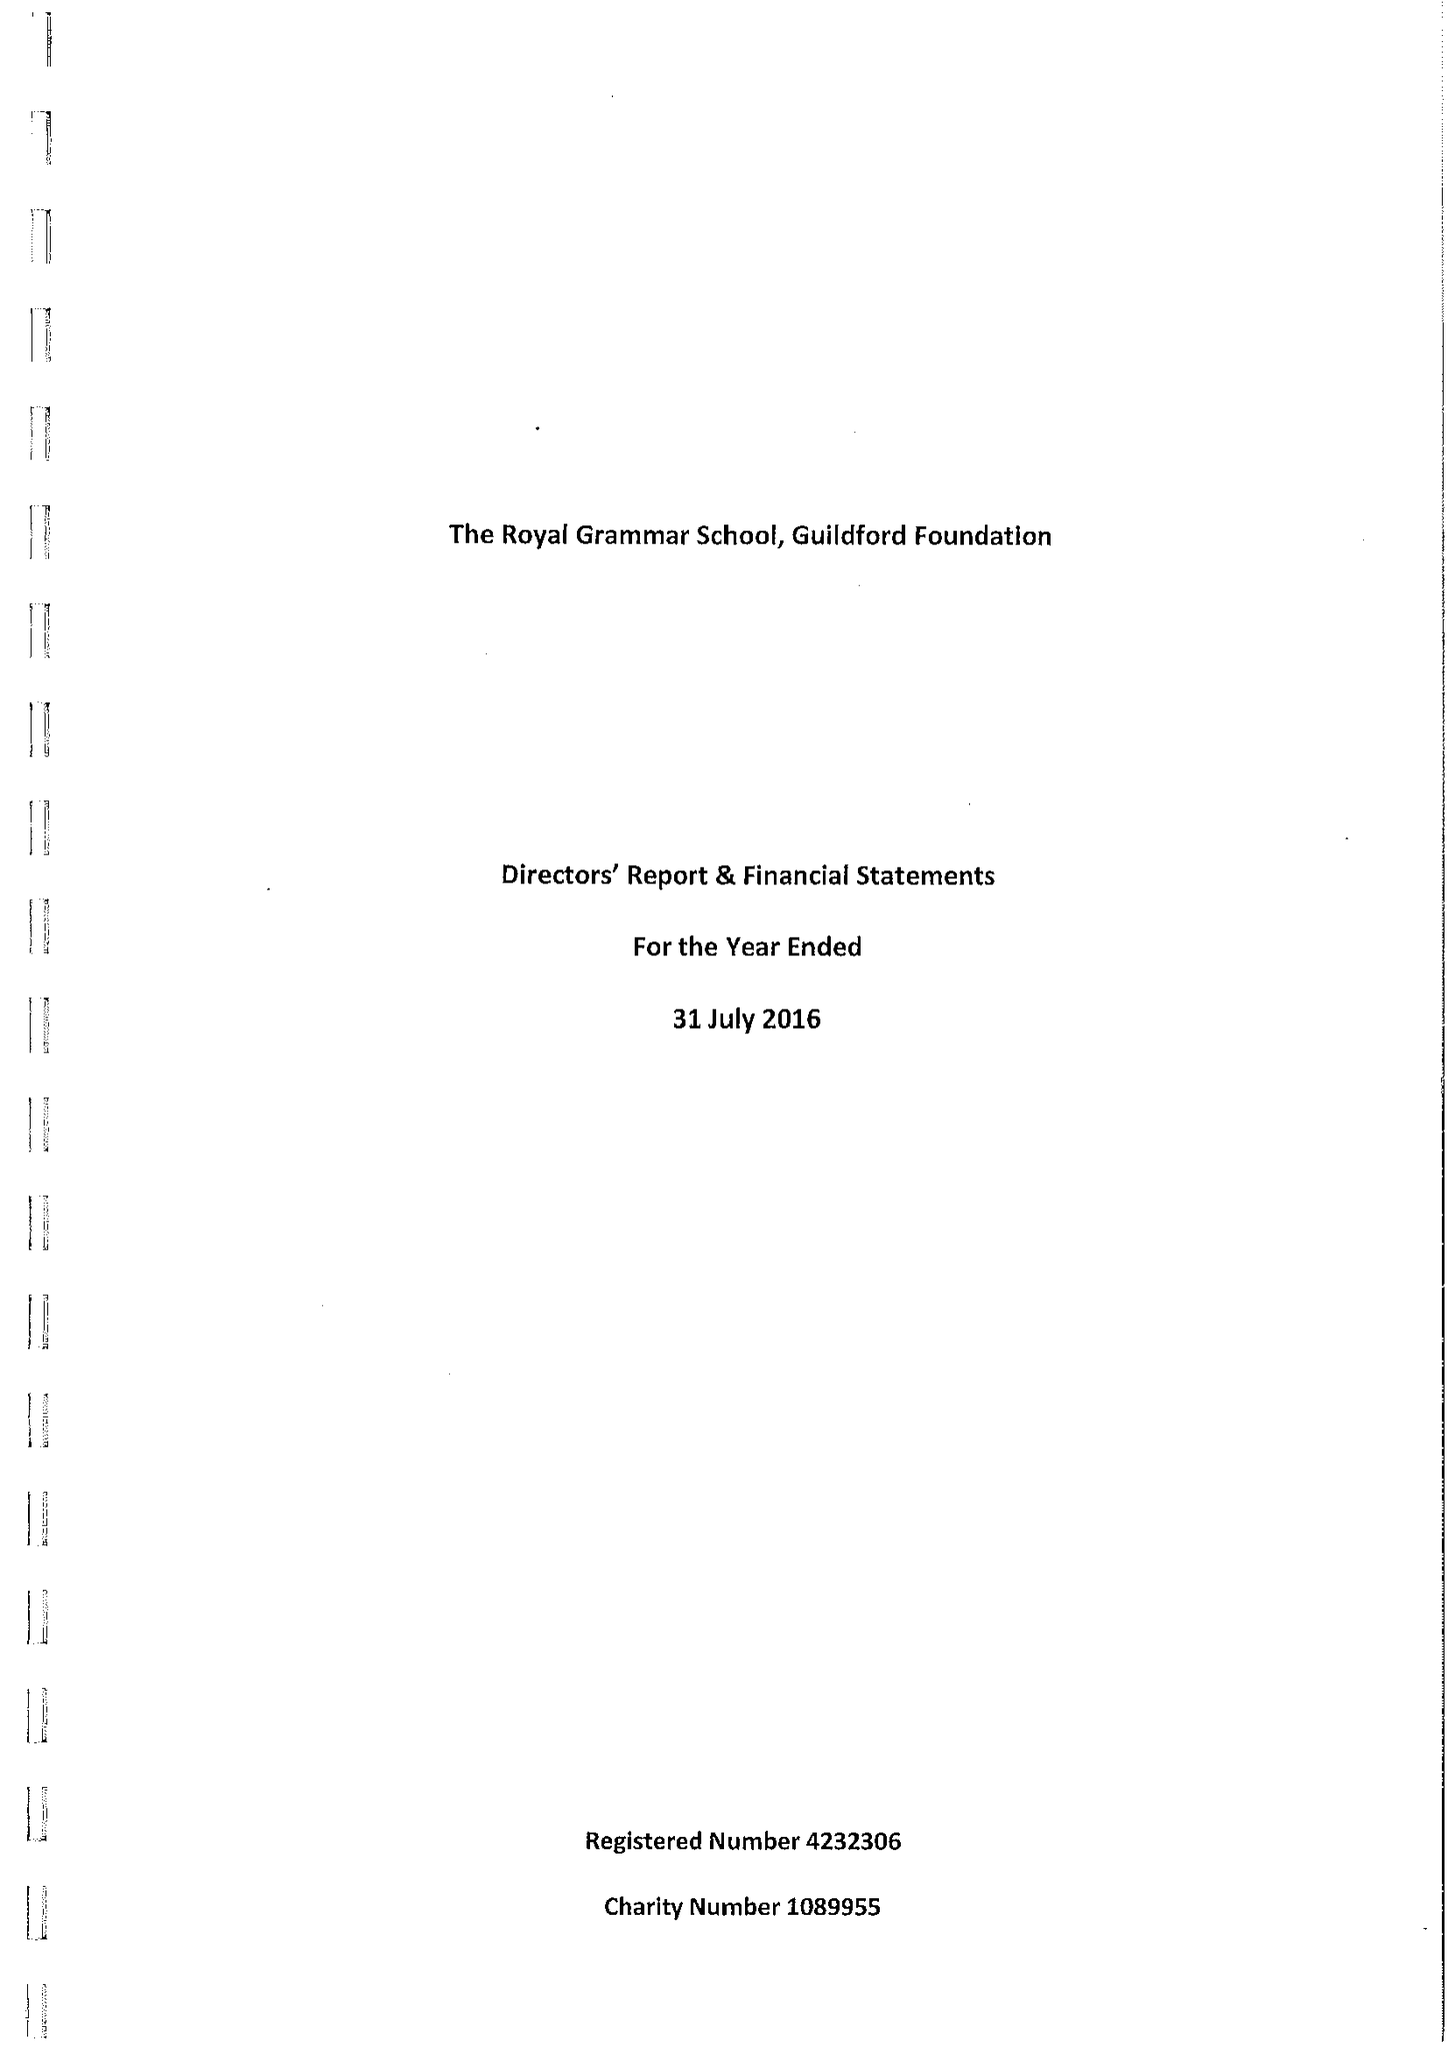What is the value for the address__post_town?
Answer the question using a single word or phrase. GUILDFORD 